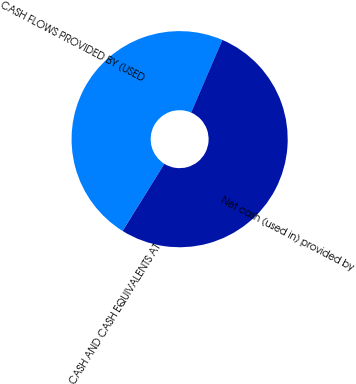<chart> <loc_0><loc_0><loc_500><loc_500><pie_chart><fcel>CASH FLOWS PROVIDED BY (USED<fcel>Net cash (used in) provided by<fcel>CASH AND CASH EQUIVALENTS AT<nl><fcel>47.61%<fcel>52.38%<fcel>0.01%<nl></chart> 